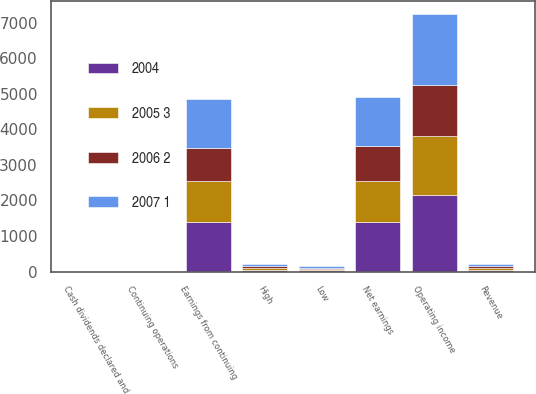<chart> <loc_0><loc_0><loc_500><loc_500><stacked_bar_chart><ecel><fcel>Revenue<fcel>Operating income<fcel>Earnings from continuing<fcel>Net earnings<fcel>Continuing operations<fcel>Cash dividends declared and<fcel>High<fcel>Low<nl><fcel>2004<fcel>54.95<fcel>2161<fcel>1407<fcel>1407<fcel>3.12<fcel>0.46<fcel>53.9<fcel>41.85<nl><fcel>2007 1<fcel>54.95<fcel>1999<fcel>1377<fcel>1377<fcel>2.79<fcel>0.36<fcel>59.5<fcel>43.51<nl><fcel>2005 3<fcel>54.95<fcel>1644<fcel>1140<fcel>1140<fcel>2.27<fcel>0.31<fcel>56<fcel>31.93<nl><fcel>2006 2<fcel>54.95<fcel>1442<fcel>934<fcel>984<fcel>1.86<fcel>0.28<fcel>41.47<fcel>29.25<nl></chart> 